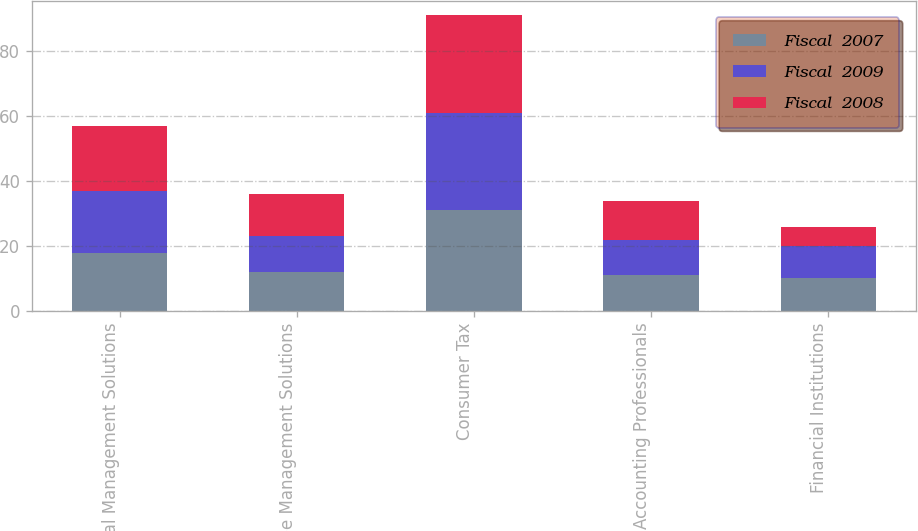Convert chart to OTSL. <chart><loc_0><loc_0><loc_500><loc_500><stacked_bar_chart><ecel><fcel>Financial Management Solutions<fcel>Employee Management Solutions<fcel>Consumer Tax<fcel>Accounting Professionals<fcel>Financial Institutions<nl><fcel>Fiscal  2007<fcel>18<fcel>12<fcel>31<fcel>11<fcel>10<nl><fcel>Fiscal  2009<fcel>19<fcel>11<fcel>30<fcel>11<fcel>10<nl><fcel>Fiscal  2008<fcel>20<fcel>13<fcel>30<fcel>12<fcel>6<nl></chart> 